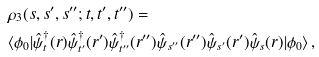Convert formula to latex. <formula><loc_0><loc_0><loc_500><loc_500>& \rho _ { 3 } ( s , s ^ { \prime } , s ^ { \prime \prime } ; t , t ^ { \prime } , t ^ { \prime \prime } ) = \\ & \langle \phi _ { 0 } | \hat { \psi } _ { t } ^ { \dagger } ( r ) \hat { \psi } _ { t ^ { \prime } } ^ { \dagger } ( r ^ { \prime } ) \hat { \psi } _ { t ^ { \prime \prime } } ^ { \dagger } ( r ^ { \prime \prime } ) \hat { \psi } _ { s ^ { \prime \prime } } ( r ^ { \prime \prime } ) \hat { \psi } _ { s ^ { \prime } } ( r ^ { \prime } ) \hat { \psi } _ { s } ( r ) | \phi _ { 0 } \rangle \, ,</formula> 